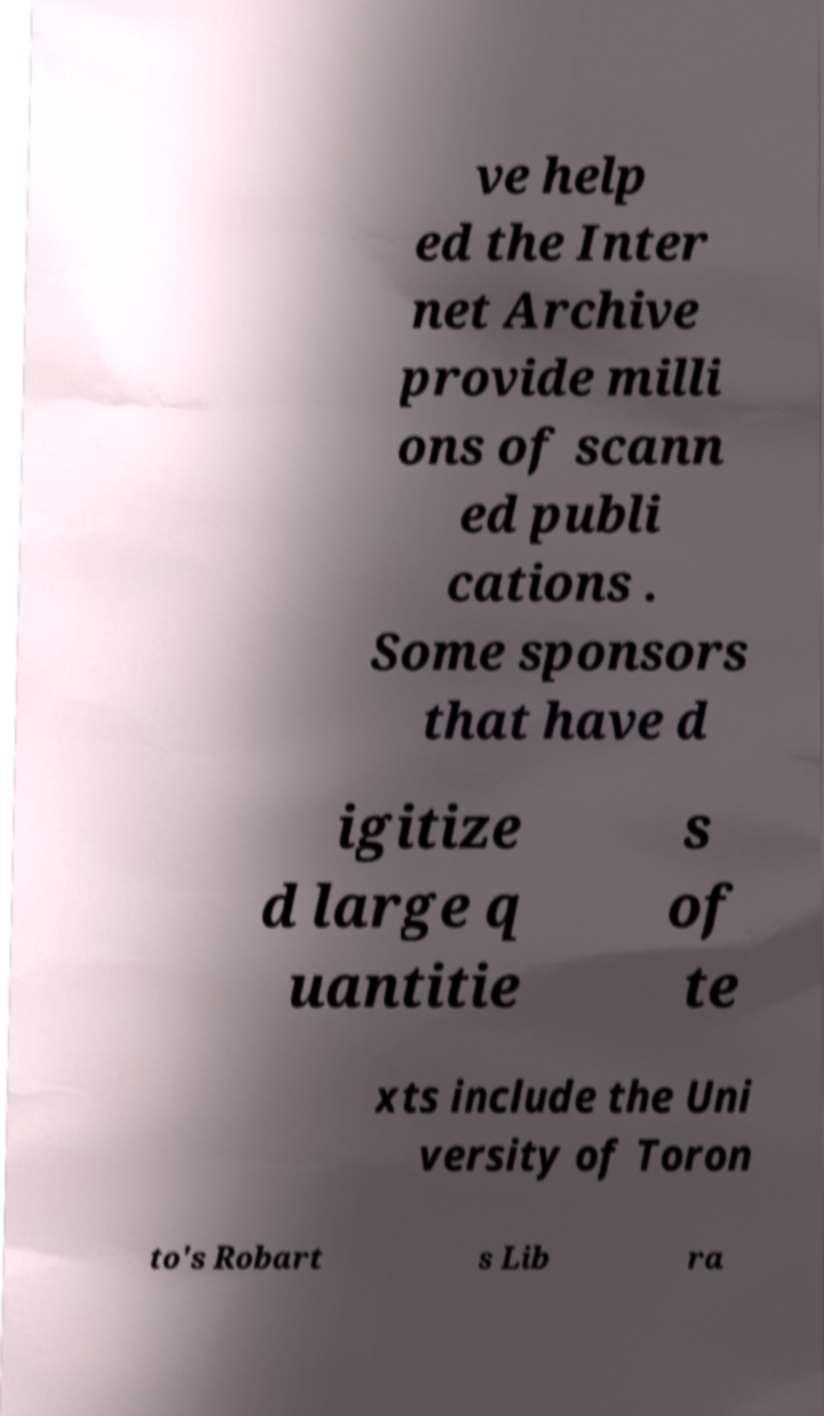Please identify and transcribe the text found in this image. ve help ed the Inter net Archive provide milli ons of scann ed publi cations . Some sponsors that have d igitize d large q uantitie s of te xts include the Uni versity of Toron to's Robart s Lib ra 